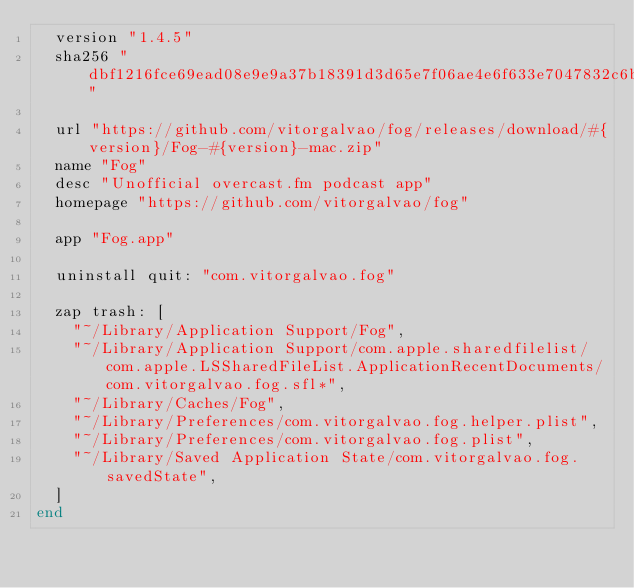Convert code to text. <code><loc_0><loc_0><loc_500><loc_500><_Ruby_>  version "1.4.5"
  sha256 "dbf1216fce69ead08e9e9a37b18391d3d65e7f06ae4e6f633e7047832c6b1adc"

  url "https://github.com/vitorgalvao/fog/releases/download/#{version}/Fog-#{version}-mac.zip"
  name "Fog"
  desc "Unofficial overcast.fm podcast app"
  homepage "https://github.com/vitorgalvao/fog"

  app "Fog.app"

  uninstall quit: "com.vitorgalvao.fog"

  zap trash: [
    "~/Library/Application Support/Fog",
    "~/Library/Application Support/com.apple.sharedfilelist/com.apple.LSSharedFileList.ApplicationRecentDocuments/com.vitorgalvao.fog.sfl*",
    "~/Library/Caches/Fog",
    "~/Library/Preferences/com.vitorgalvao.fog.helper.plist",
    "~/Library/Preferences/com.vitorgalvao.fog.plist",
    "~/Library/Saved Application State/com.vitorgalvao.fog.savedState",
  ]
end
</code> 